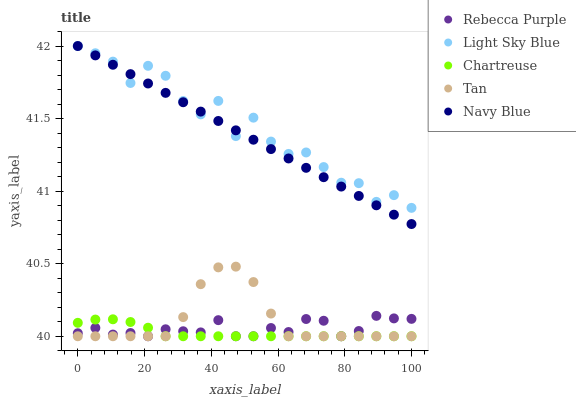Does Chartreuse have the minimum area under the curve?
Answer yes or no. Yes. Does Light Sky Blue have the maximum area under the curve?
Answer yes or no. Yes. Does Light Sky Blue have the minimum area under the curve?
Answer yes or no. No. Does Chartreuse have the maximum area under the curve?
Answer yes or no. No. Is Navy Blue the smoothest?
Answer yes or no. Yes. Is Light Sky Blue the roughest?
Answer yes or no. Yes. Is Chartreuse the smoothest?
Answer yes or no. No. Is Chartreuse the roughest?
Answer yes or no. No. Does Chartreuse have the lowest value?
Answer yes or no. Yes. Does Light Sky Blue have the lowest value?
Answer yes or no. No. Does Light Sky Blue have the highest value?
Answer yes or no. Yes. Does Chartreuse have the highest value?
Answer yes or no. No. Is Tan less than Light Sky Blue?
Answer yes or no. Yes. Is Light Sky Blue greater than Rebecca Purple?
Answer yes or no. Yes. Does Light Sky Blue intersect Navy Blue?
Answer yes or no. Yes. Is Light Sky Blue less than Navy Blue?
Answer yes or no. No. Is Light Sky Blue greater than Navy Blue?
Answer yes or no. No. Does Tan intersect Light Sky Blue?
Answer yes or no. No. 